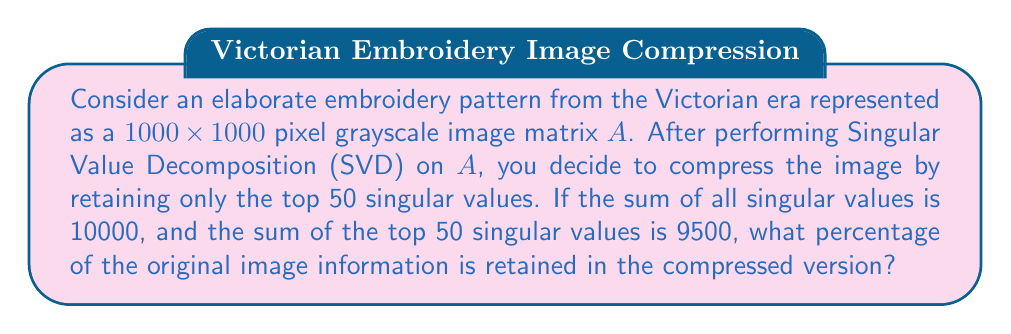Can you solve this math problem? Let's approach this step-by-step:

1) First, recall that in SVD, a matrix $A$ is decomposed as:

   $$A = U\Sigma V^T$$

   where $\Sigma$ is a diagonal matrix containing the singular values.

2) The singular values represent the importance of each "feature" in the image. Larger singular values correspond to more important features.

3) The total "energy" or information in the image is proportional to the sum of the squares of all singular values. However, in this case, we're given the sum of the singular values directly.

4) Let's define:
   - $s_{total}$ = sum of all singular values = 10000
   - $s_{50}$ = sum of top 50 singular values = 9500

5) The percentage of information retained is the ratio of the sum of the top 50 singular values to the sum of all singular values:

   $$\text{Information Retained} = \frac{s_{50}}{s_{total}} \times 100\%$$

6) Substituting the values:

   $$\text{Information Retained} = \frac{9500}{10000} \times 100\% = 0.95 \times 100\% = 95\%$$

Therefore, by retaining only the top 50 singular values, we preserve 95% of the original image information.
Answer: 95% 